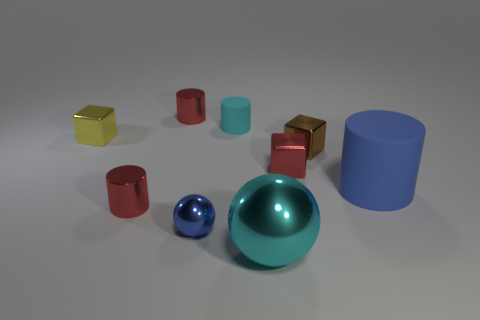What number of red objects are tiny balls or cylinders?
Give a very brief answer. 2. How many blue spheres are the same size as the brown shiny block?
Offer a very short reply. 1. Do the blue object that is left of the large cyan metal object and the brown object have the same material?
Provide a succinct answer. Yes. There is a small red metal cylinder in front of the small yellow metal object; are there any blue things that are in front of it?
Offer a terse response. Yes. There is another big object that is the same shape as the cyan rubber thing; what is it made of?
Offer a terse response. Rubber. Are there more metal cylinders that are behind the tiny brown block than large objects that are in front of the cyan metal thing?
Provide a short and direct response. Yes. There is a small object that is the same material as the blue cylinder; what is its shape?
Your response must be concise. Cylinder. Are there more cylinders in front of the cyan rubber cylinder than cyan cylinders?
Give a very brief answer. Yes. How many objects have the same color as the big matte cylinder?
Give a very brief answer. 1. How many other things are there of the same color as the tiny metallic ball?
Your response must be concise. 1. 